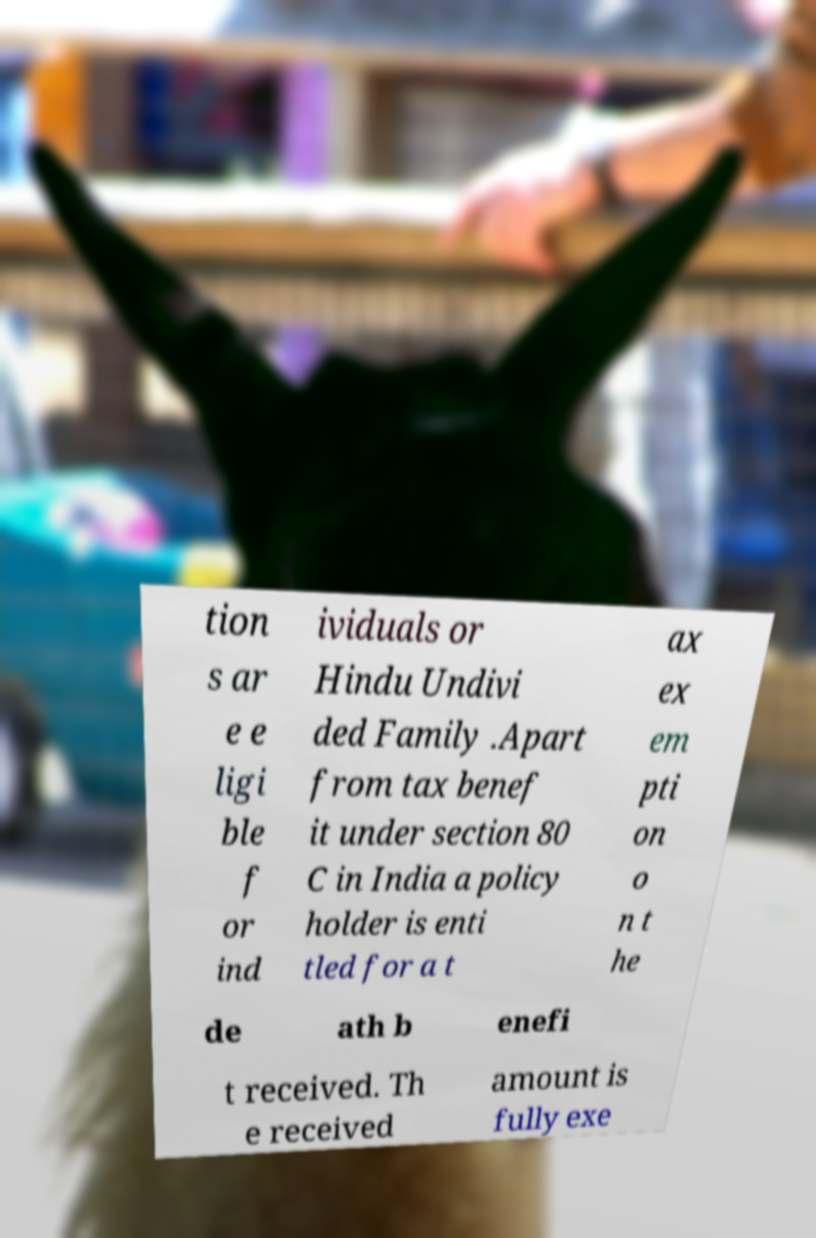Please read and relay the text visible in this image. What does it say? tion s ar e e ligi ble f or ind ividuals or Hindu Undivi ded Family .Apart from tax benef it under section 80 C in India a policy holder is enti tled for a t ax ex em pti on o n t he de ath b enefi t received. Th e received amount is fully exe 